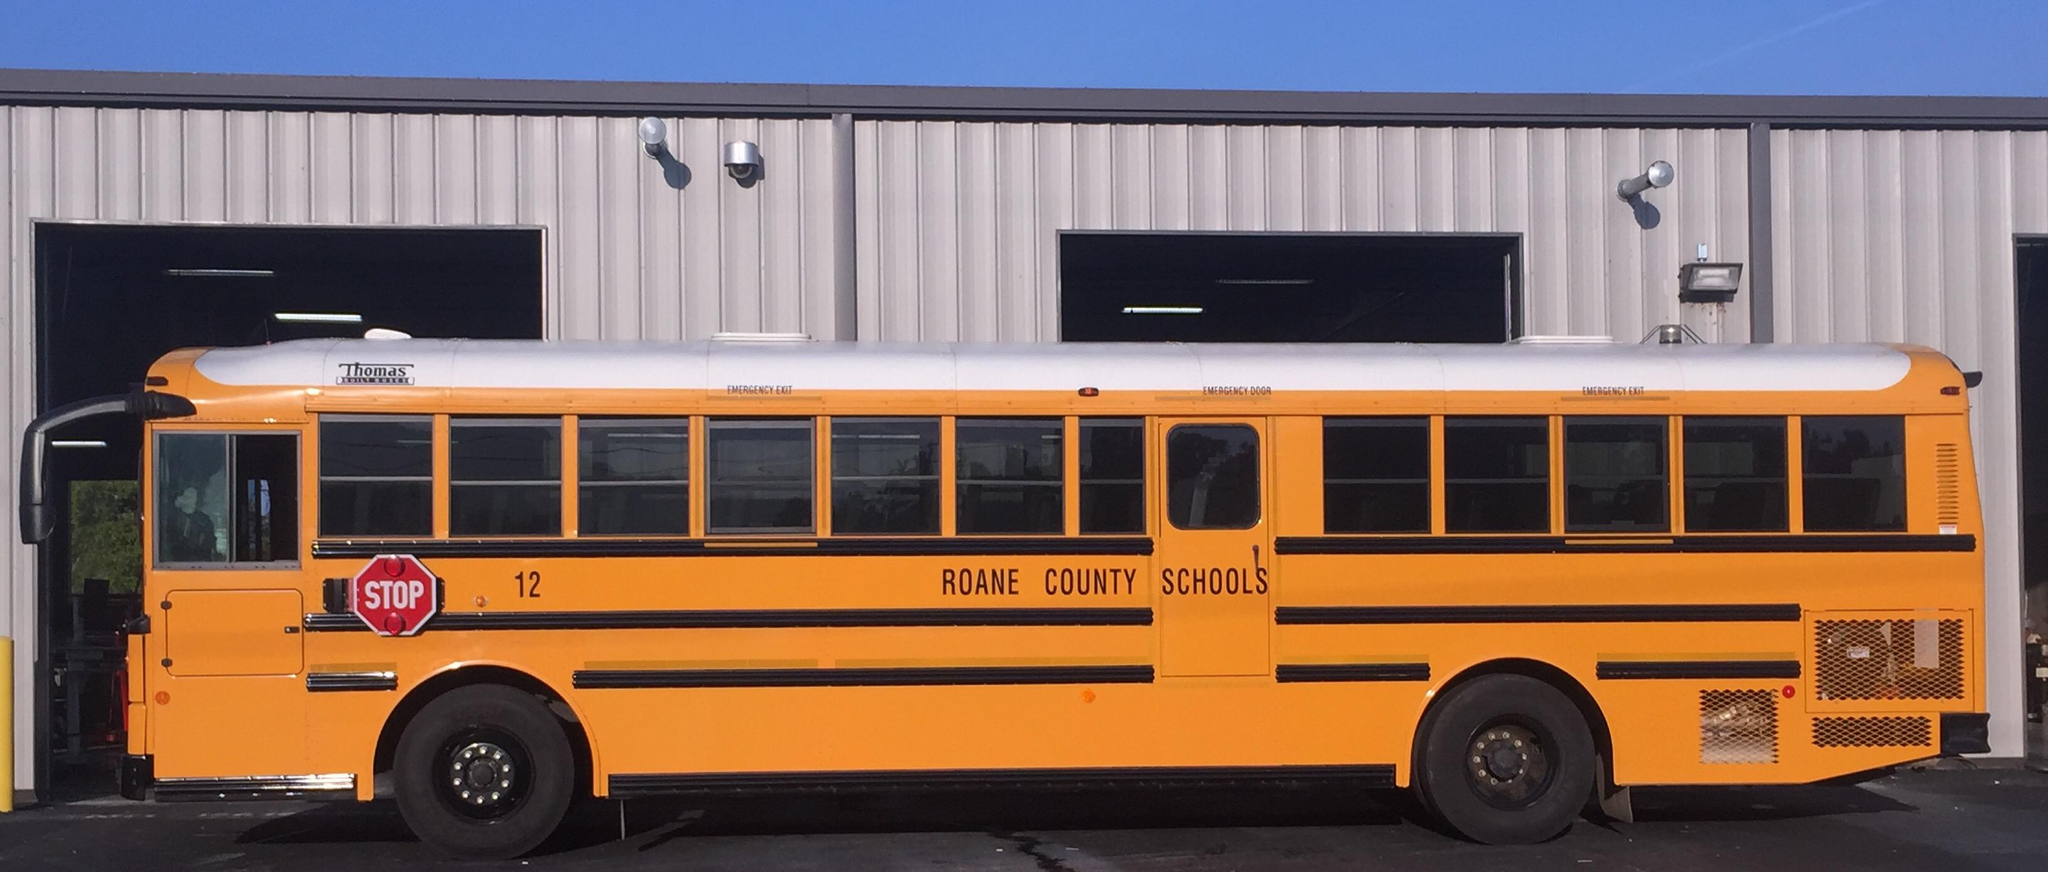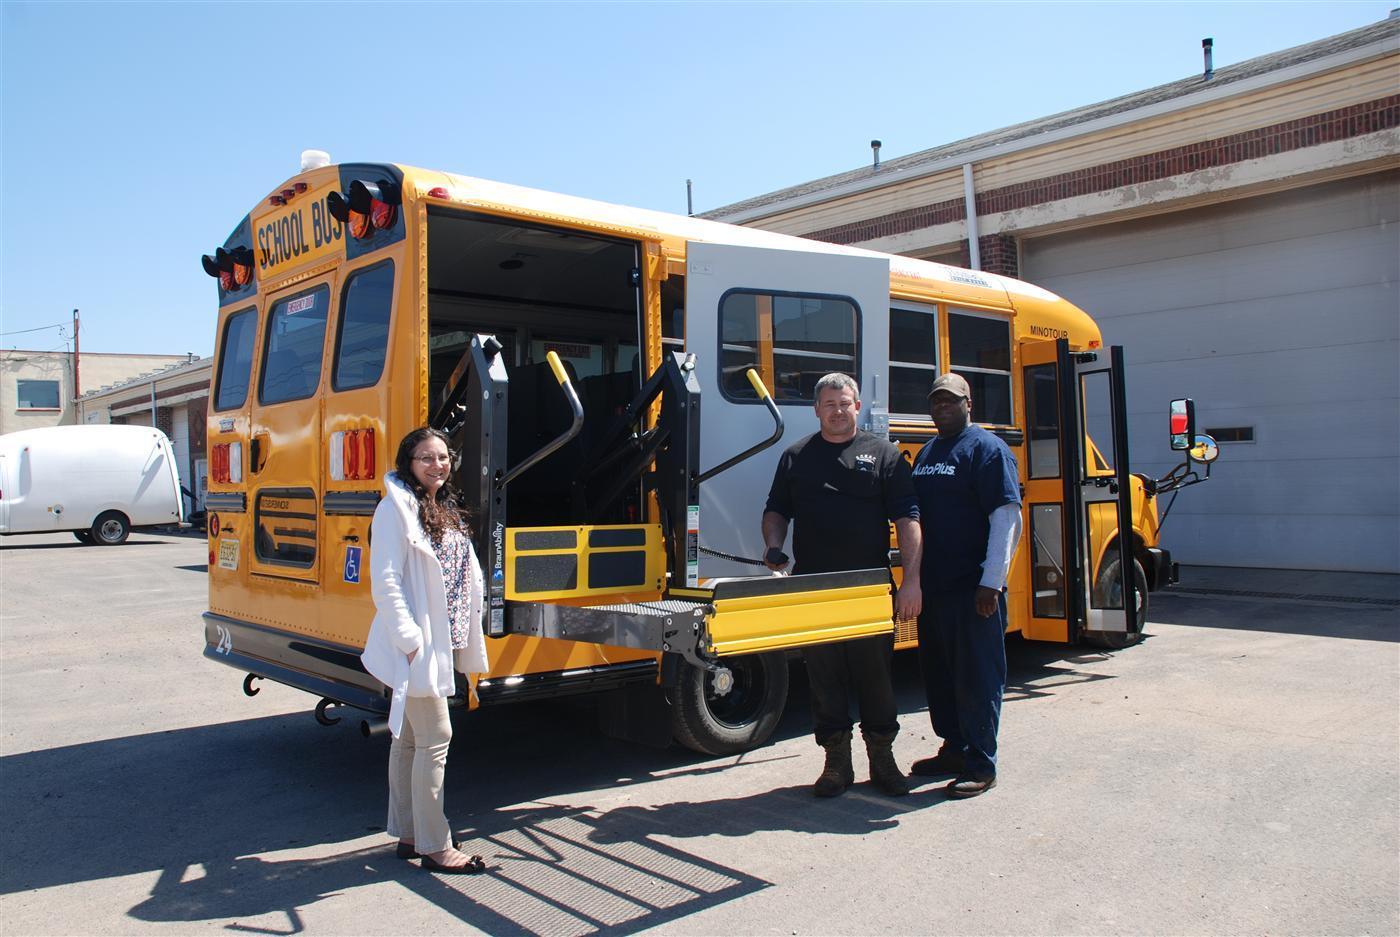The first image is the image on the left, the second image is the image on the right. For the images displayed, is the sentence "One image shows a horizontal view of a long bus with an extra door on the side near the middle of the bus." factually correct? Answer yes or no. Yes. The first image is the image on the left, the second image is the image on the right. Analyze the images presented: Is the assertion "One bus' passenger door is open." valid? Answer yes or no. Yes. 